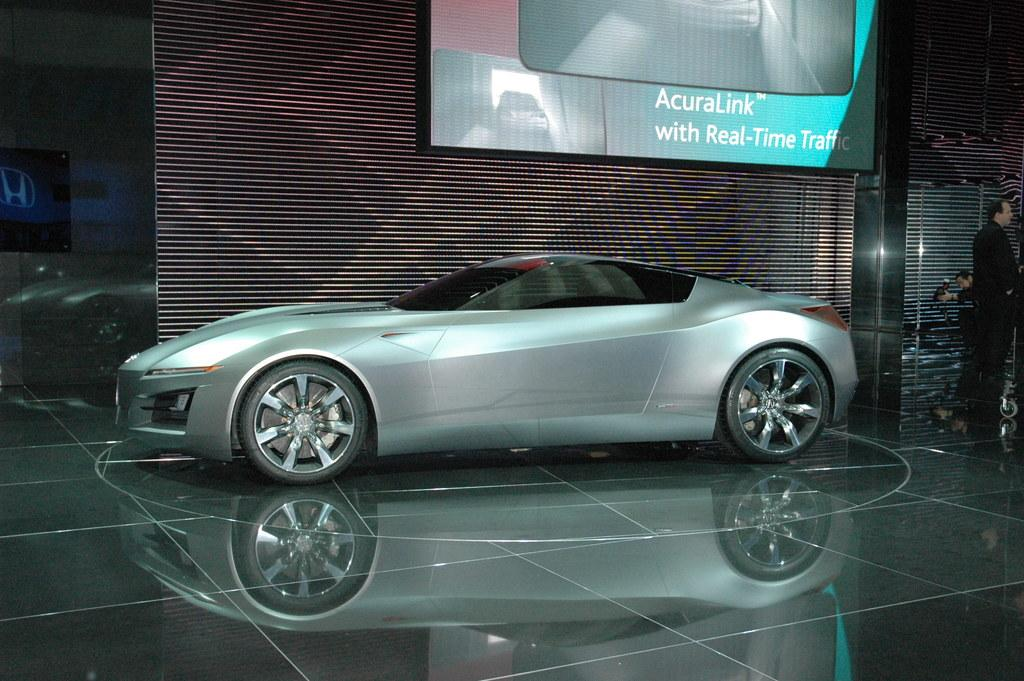What is the main subject of the image? The main subject of the image is a car. What is the color of the floor on which the car is placed? The car is on a black floor. What can be seen in the background of the image? There is a board visible in the background, and there are people present as well. How would you describe the lighting in the image? The background is dark. How many rabbits are present in the car's territory in the image? There are no rabbits or territories mentioned in the image; it features a car on a black floor with a dark background. 